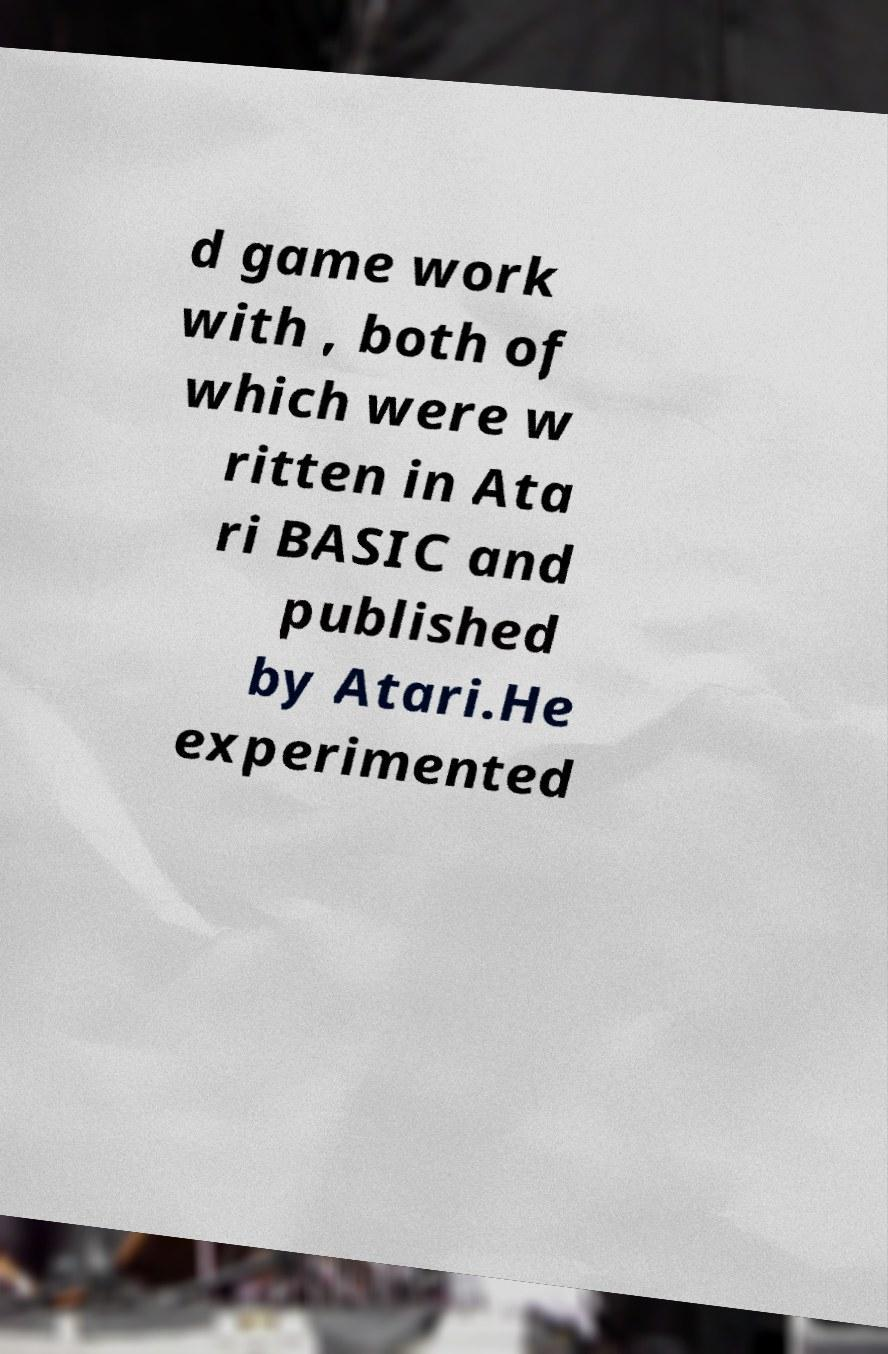For documentation purposes, I need the text within this image transcribed. Could you provide that? d game work with , both of which were w ritten in Ata ri BASIC and published by Atari.He experimented 